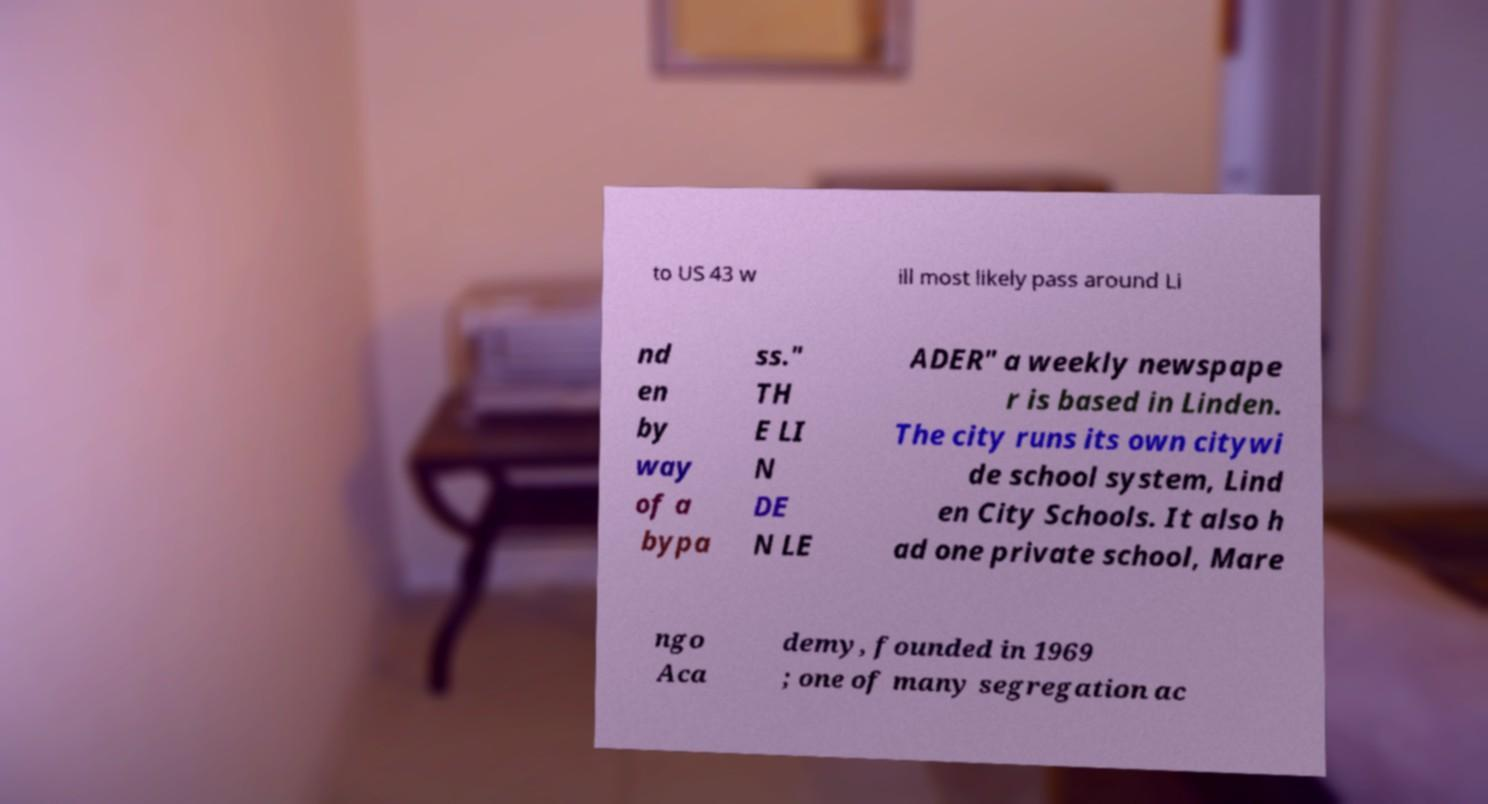Could you extract and type out the text from this image? to US 43 w ill most likely pass around Li nd en by way of a bypa ss." TH E LI N DE N LE ADER" a weekly newspape r is based in Linden. The city runs its own citywi de school system, Lind en City Schools. It also h ad one private school, Mare ngo Aca demy, founded in 1969 ; one of many segregation ac 